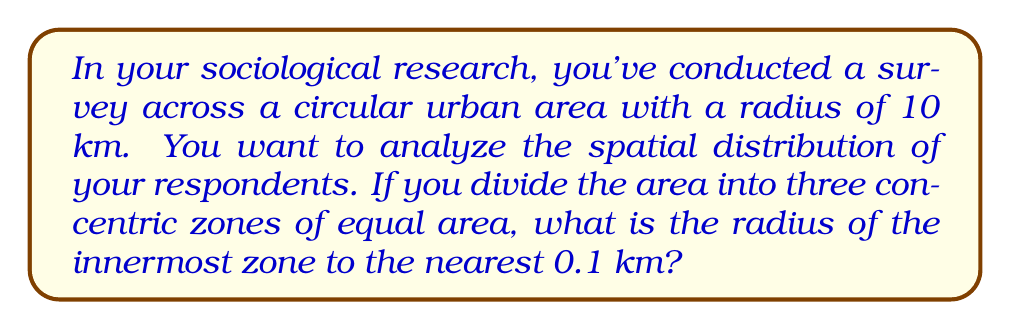Can you answer this question? Let's approach this step-by-step:

1) The total area of the circular urban region is:
   $$A_{total} = \pi r^2 = \pi (10 \text{ km})^2 = 100\pi \text{ km}^2$$

2) We need to divide this into three equal areas. So each zone should have an area of:
   $$A_{zone} = \frac{A_{total}}{3} = \frac{100\pi}{3} \text{ km}^2$$

3) Let the radius of the innermost zone be $x$ km. Its area should be equal to $A_{zone}$:
   $$\pi x^2 = \frac{100\pi}{3}$$

4) Simplify by dividing both sides by $\pi$:
   $$x^2 = \frac{100}{3}$$

5) Take the square root of both sides:
   $$x = \sqrt{\frac{100}{3}} \approx 5.77 \text{ km}$$

6) Rounding to the nearest 0.1 km:
   $$x \approx 5.8 \text{ km}$$

This method ensures that each zone has an equal area, which is crucial for unbiased spatial analysis in sociological research using qualitative methods.
Answer: 5.8 km 